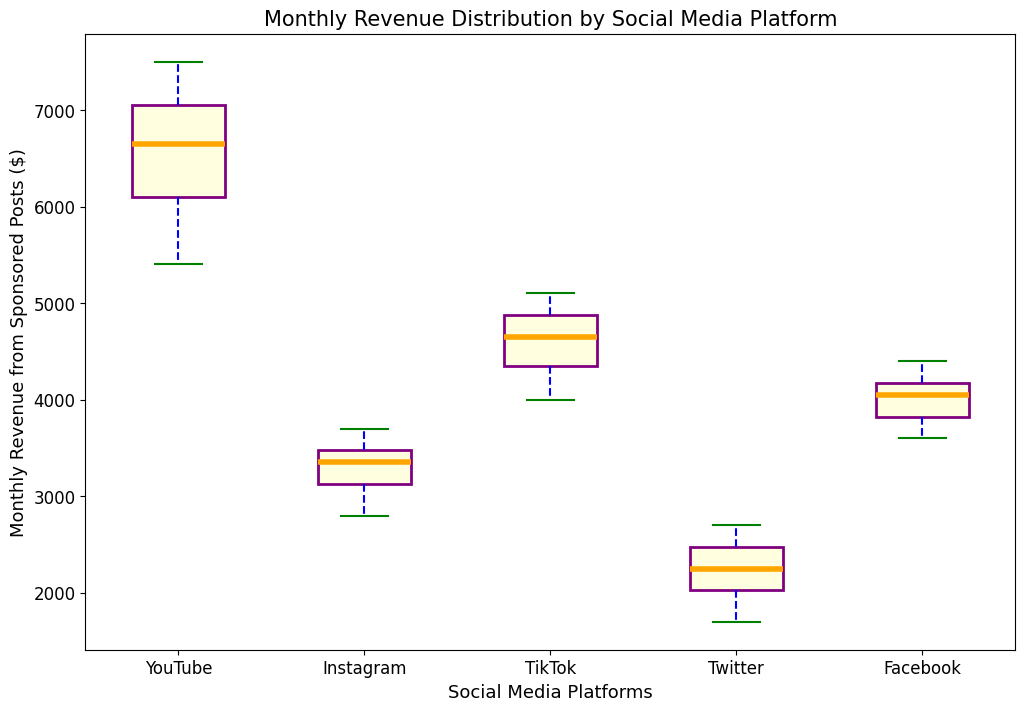What's the median revenue for Instagram? To find the median, you first need to order the data points for Instagram in ascending order: 2800, 3000, 3100, 3200, 3300, 3400, 3400, 3500, 3600, 3700. Since there are 10 data points, the median will be the average of the 5th and 6th values: (3300 + 3400) / 2 = 3350
Answer: 3350 Which platform has the highest median revenue? By looking at the boxplot, the highest median value is represented by the thick orange line inside the box. Among all platforms, YouTube has the highest orange line indicating the highest median revenue.
Answer: YouTube How does the median revenue of TikTok compare to that of Facebook? Comparing the orange lines in the box for TikTok and Facebook, we see that TikTok's median line is higher than Facebook's. Thus, TikTok has a higher median revenue than Facebook.
Answer: TikTok What is the interquartile range (IQR) for Twitter? The IQR is the difference between the third quartile (Q3) and the first quartile (Q1). For Twitter, visually determine the top and bottom of the box (the edges), and subtract the lower value from the higher value. Specific values may not be given numerically but should be visually estimated.
Answer: (Estimated by visual inspection, such as Q3 ≈ 2600 and Q1 ≈ 2000, thus IQR ≈ 2600-2000=600) Which platform has the widest spread of monthly revenue? The spread is represented by the length of the whiskers in the boxplot. Among all platforms, YouTube has the whiskers extending the furthest apart, indicating the widest spread of monthly revenues.
Answer: YouTube Are there any outliers in the revenue for Twitter? Outliers are represented by individual points beyond the whiskers of the boxplot. For Twitter, there are no points beyond the whiskers, indicating there are no outliers.
Answer: No Which platform shows the smallest range between the maximum and minimum revenue? The range is determined by the length of the whiskers. Instagram has the shortest whiskers, indicating the smallest range between the maximum and minimum revenue.
Answer: Instagram 